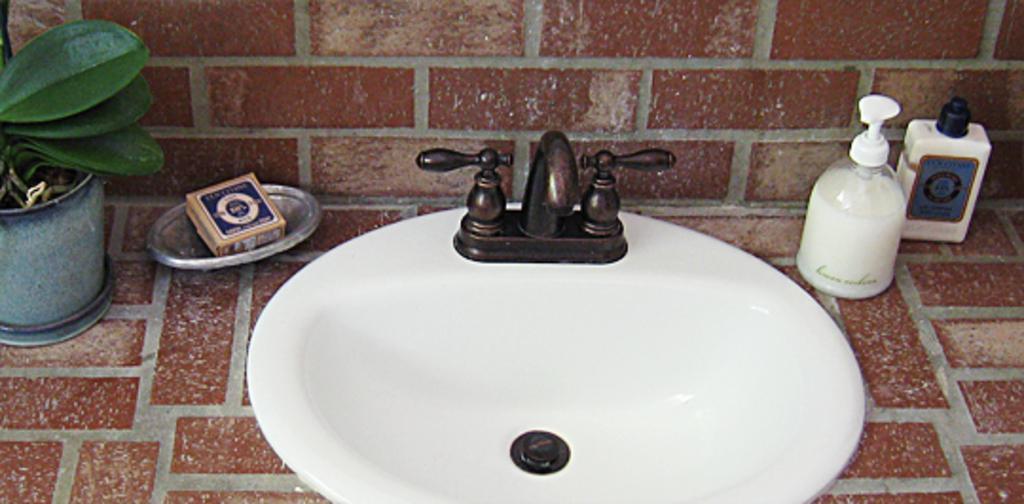Can you describe this image briefly? In this image there is washbasin, tap, bottles, matchbox on the soap tray, plant on the cabinet. 